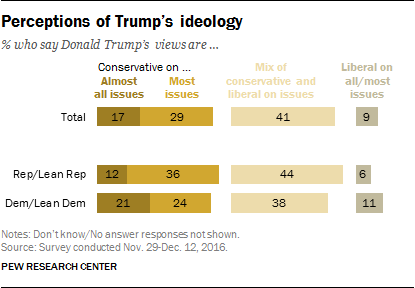Point out several critical features in this image. The number of colors used to represent different views is 4. According to a recent survey, a significant percentage of Democrats and those who identify as "Lean Democrat" believe that Donald Trump's views are liberal on most or all issues. 